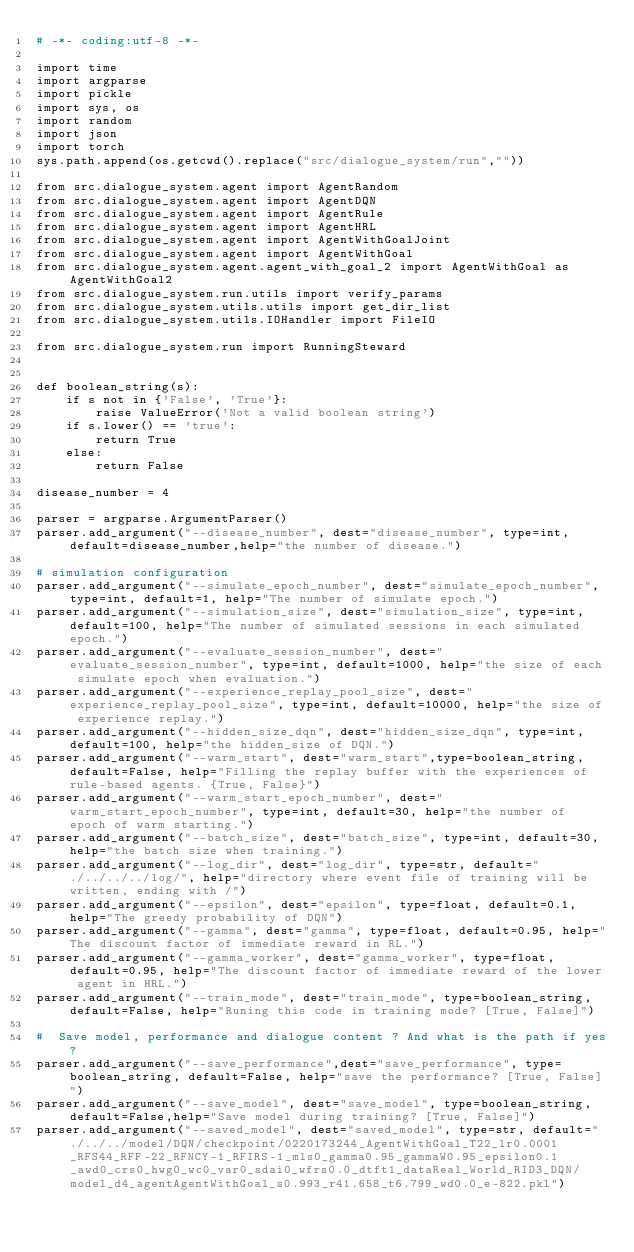<code> <loc_0><loc_0><loc_500><loc_500><_Python_># -*- coding:utf-8 -*-

import time
import argparse
import pickle
import sys, os
import random
import json
import torch
sys.path.append(os.getcwd().replace("src/dialogue_system/run",""))

from src.dialogue_system.agent import AgentRandom
from src.dialogue_system.agent import AgentDQN
from src.dialogue_system.agent import AgentRule
from src.dialogue_system.agent import AgentHRL
from src.dialogue_system.agent import AgentWithGoalJoint
from src.dialogue_system.agent import AgentWithGoal
from src.dialogue_system.agent.agent_with_goal_2 import AgentWithGoal as AgentWithGoal2
from src.dialogue_system.run.utils import verify_params
from src.dialogue_system.utils.utils import get_dir_list
from src.dialogue_system.utils.IOHandler import FileIO

from src.dialogue_system.run import RunningSteward


def boolean_string(s):
    if s not in {'False', 'True'}:
        raise ValueError('Not a valid boolean string')
    if s.lower() == 'true':
        return True
    else:
        return False

disease_number = 4

parser = argparse.ArgumentParser()
parser.add_argument("--disease_number", dest="disease_number", type=int,default=disease_number,help="the number of disease.")

# simulation configuration
parser.add_argument("--simulate_epoch_number", dest="simulate_epoch_number", type=int, default=1, help="The number of simulate epoch.")
parser.add_argument("--simulation_size", dest="simulation_size", type=int, default=100, help="The number of simulated sessions in each simulated epoch.")
parser.add_argument("--evaluate_session_number", dest="evaluate_session_number", type=int, default=1000, help="the size of each simulate epoch when evaluation.")
parser.add_argument("--experience_replay_pool_size", dest="experience_replay_pool_size", type=int, default=10000, help="the size of experience replay.")
parser.add_argument("--hidden_size_dqn", dest="hidden_size_dqn", type=int, default=100, help="the hidden_size of DQN.")
parser.add_argument("--warm_start", dest="warm_start",type=boolean_string, default=False, help="Filling the replay buffer with the experiences of rule-based agents. {True, False}")
parser.add_argument("--warm_start_epoch_number", dest="warm_start_epoch_number", type=int, default=30, help="the number of epoch of warm starting.")
parser.add_argument("--batch_size", dest="batch_size", type=int, default=30, help="the batch size when training.")
parser.add_argument("--log_dir", dest="log_dir", type=str, default="./../../../log/", help="directory where event file of training will be written, ending with /")
parser.add_argument("--epsilon", dest="epsilon", type=float, default=0.1, help="The greedy probability of DQN")
parser.add_argument("--gamma", dest="gamma", type=float, default=0.95, help="The discount factor of immediate reward in RL.")
parser.add_argument("--gamma_worker", dest="gamma_worker", type=float, default=0.95, help="The discount factor of immediate reward of the lower agent in HRL.")
parser.add_argument("--train_mode", dest="train_mode", type=boolean_string, default=False, help="Runing this code in training mode? [True, False]")

#  Save model, performance and dialogue content ? And what is the path if yes?
parser.add_argument("--save_performance",dest="save_performance", type=boolean_string, default=False, help="save the performance? [True, False]")
parser.add_argument("--save_model", dest="save_model", type=boolean_string, default=False,help="Save model during training? [True, False]")
parser.add_argument("--saved_model", dest="saved_model", type=str, default="./../../model/DQN/checkpoint/0220173244_AgentWithGoal_T22_lr0.0001_RFS44_RFF-22_RFNCY-1_RFIRS-1_mls0_gamma0.95_gammaW0.95_epsilon0.1_awd0_crs0_hwg0_wc0_var0_sdai0_wfrs0.0_dtft1_dataReal_World_RID3_DQN/model_d4_agentAgentWithGoal_s0.993_r41.658_t6.799_wd0.0_e-822.pkl")</code> 